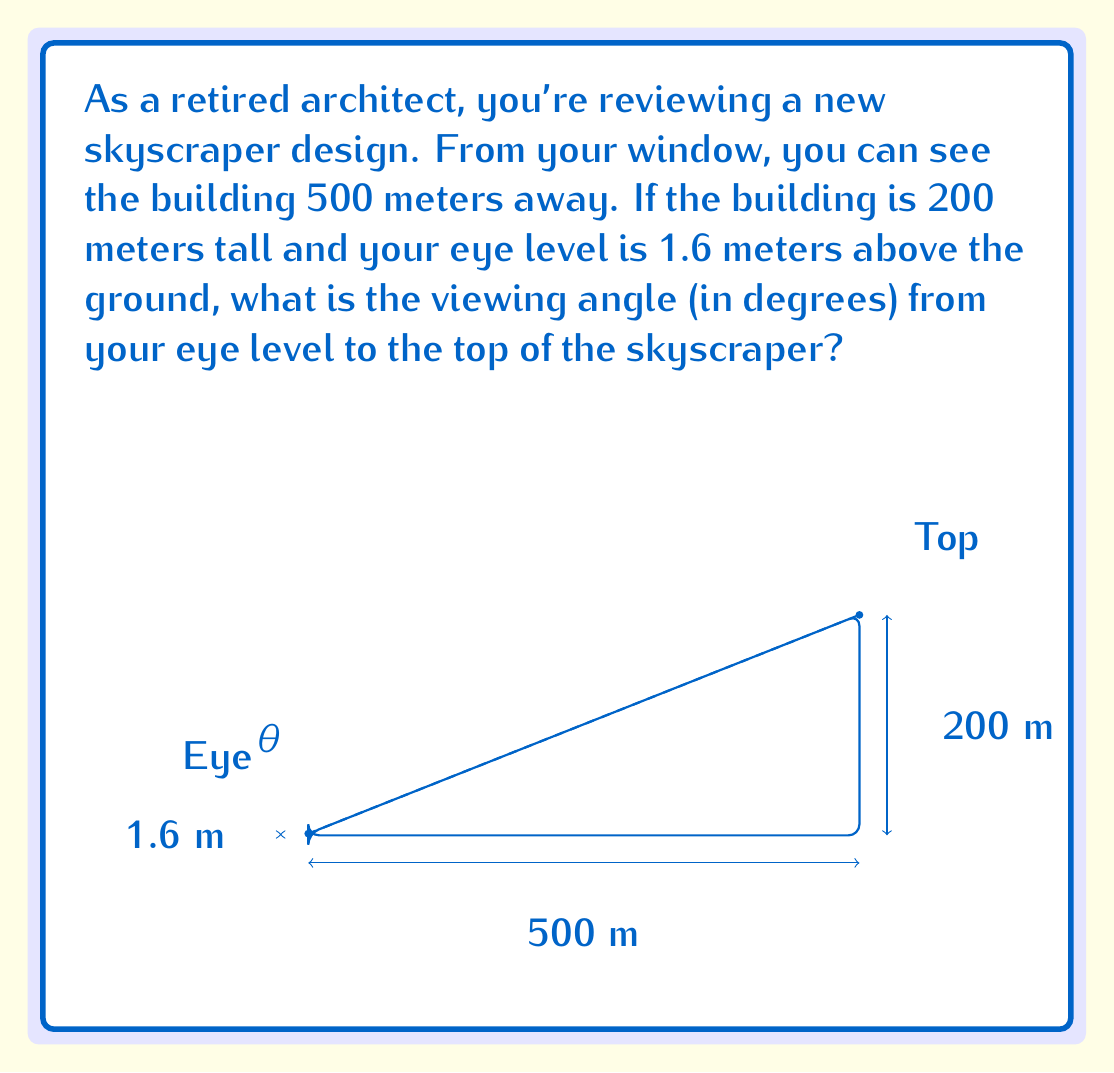Give your solution to this math problem. Let's approach this step-by-step:

1) First, we need to identify the right triangle formed by your eye level, the top of the building, and the ground.

2) We know:
   - The adjacent side (ground distance) = 500 m
   - The opposite side = Building height - Eye level = 200 m - 1.6 m = 198.4 m

3) To find the angle, we can use the arctangent function:

   $$\theta = \arctan(\frac{\text{opposite}}{\text{adjacent}})$$

4) Plugging in our values:

   $$\theta = \arctan(\frac{198.4}{500})$$

5) Using a calculator:

   $$\theta = \arctan(0.3968) \approx 0.3799 \text{ radians}$$

6) Convert radians to degrees:

   $$\theta = 0.3799 \times \frac{180^{\circ}}{\pi} \approx 21.76^{\circ}$$

Therefore, the viewing angle from your eye level to the top of the skyscraper is approximately 21.76°.
Answer: $21.76^{\circ}$ 